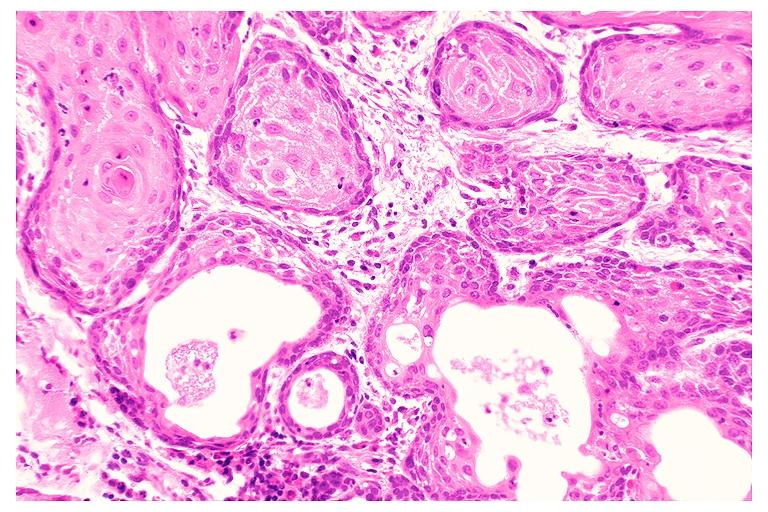what does this image show?
Answer the question using a single word or phrase. Necrotizing sialometaplasia 